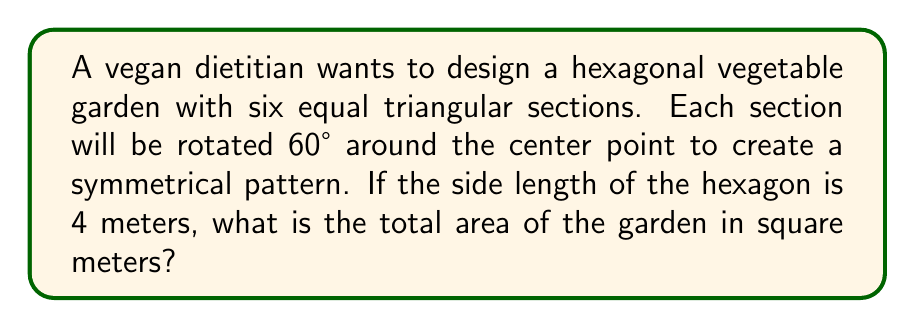Can you answer this question? Let's approach this step-by-step:

1) First, we need to understand that the hexagon is made up of six equilateral triangles.

2) The area of a regular hexagon is given by the formula:

   $$A = \frac{3\sqrt{3}}{2}s^2$$

   where $s$ is the side length of the hexagon.

3) We're given that the side length is 4 meters. Let's substitute this into our formula:

   $$A = \frac{3\sqrt{3}}{2}(4)^2$$

4) Simplify:
   $$A = \frac{3\sqrt{3}}{2}(16)$$
   $$A = 24\sqrt{3}$$

5) To get a decimal approximation:
   $$A \approx 24 * 1.732 \approx 41.57$$

6) Therefore, the total area of the garden is approximately 41.57 square meters.

[asy]
unitsize(20);
real s = 2;
pair[] hex = {(s,0)};
for (int i=1; i<6; ++i) {
  hex.push(rotate(60*i)*hex[0]);
}
fill(hex, palegreen);
draw(hex--cycle);
for (pair p: hex) {
  draw((0,0)--p);
}
label("4m", (s/2,0), S);
[/asy]

The diagram shows the hexagonal garden divided into six equilateral triangles, each rotated 60° from the adjacent ones, creating a symmetrical pattern ideal for diverse plant-based crop rotation.
Answer: $24\sqrt{3}$ m² (or approximately 41.57 m²) 